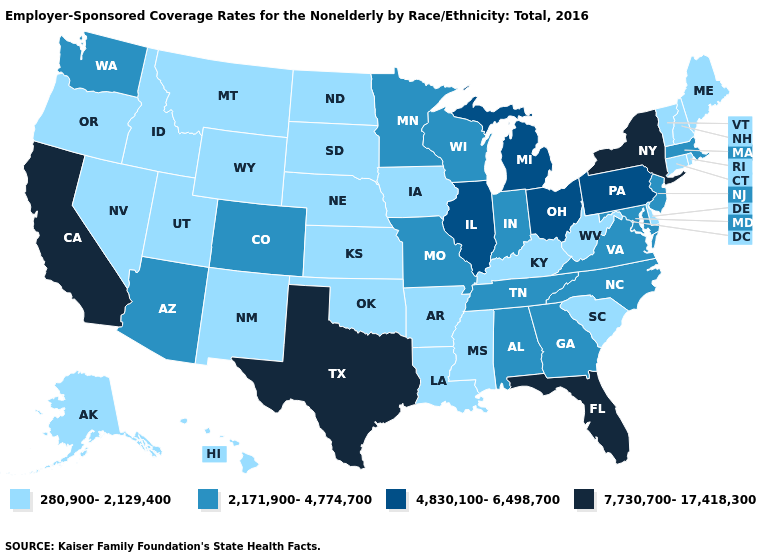Name the states that have a value in the range 7,730,700-17,418,300?
Write a very short answer. California, Florida, New York, Texas. Name the states that have a value in the range 280,900-2,129,400?
Give a very brief answer. Alaska, Arkansas, Connecticut, Delaware, Hawaii, Idaho, Iowa, Kansas, Kentucky, Louisiana, Maine, Mississippi, Montana, Nebraska, Nevada, New Hampshire, New Mexico, North Dakota, Oklahoma, Oregon, Rhode Island, South Carolina, South Dakota, Utah, Vermont, West Virginia, Wyoming. How many symbols are there in the legend?
Give a very brief answer. 4. Which states have the highest value in the USA?
Concise answer only. California, Florida, New York, Texas. What is the value of Michigan?
Write a very short answer. 4,830,100-6,498,700. What is the value of South Dakota?
Quick response, please. 280,900-2,129,400. Does Missouri have the highest value in the MidWest?
Write a very short answer. No. Does Maine have a lower value than Montana?
Quick response, please. No. Does Delaware have a lower value than Ohio?
Be succinct. Yes. How many symbols are there in the legend?
Give a very brief answer. 4. What is the value of Texas?
Write a very short answer. 7,730,700-17,418,300. Name the states that have a value in the range 280,900-2,129,400?
Be succinct. Alaska, Arkansas, Connecticut, Delaware, Hawaii, Idaho, Iowa, Kansas, Kentucky, Louisiana, Maine, Mississippi, Montana, Nebraska, Nevada, New Hampshire, New Mexico, North Dakota, Oklahoma, Oregon, Rhode Island, South Carolina, South Dakota, Utah, Vermont, West Virginia, Wyoming. Does Arizona have the highest value in the West?
Concise answer only. No. Does the first symbol in the legend represent the smallest category?
Answer briefly. Yes. 